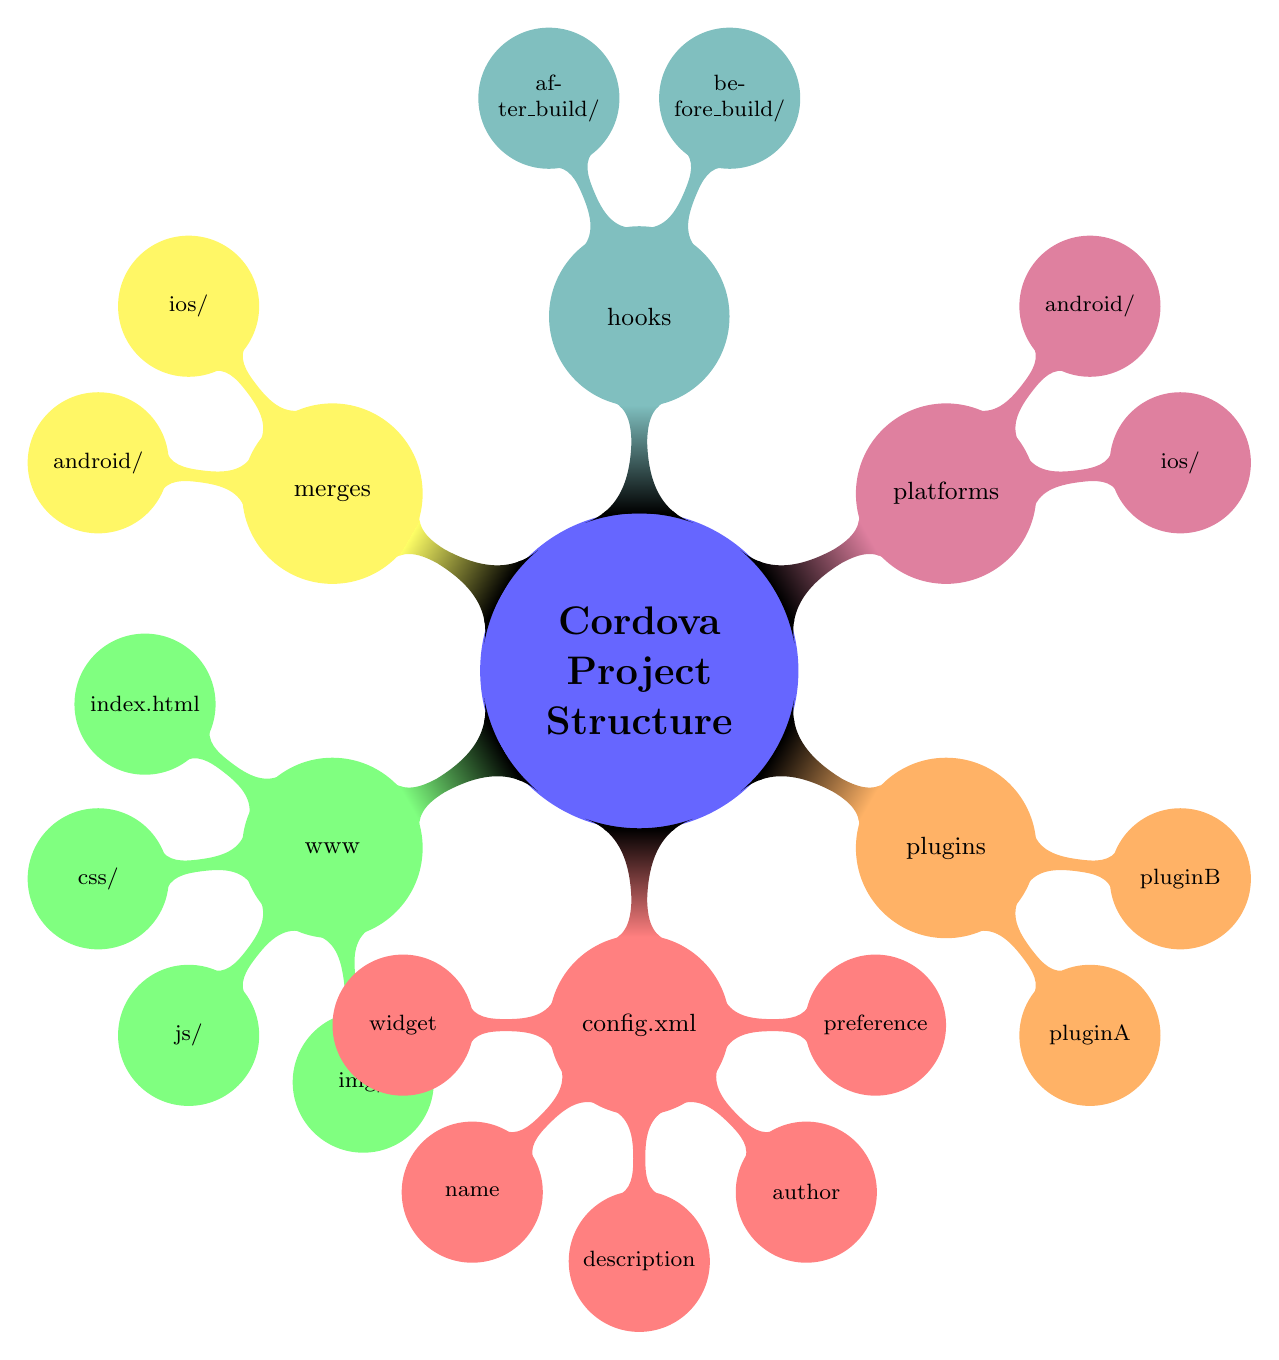What is the main entry point for the application in the www directory? The main entry point for the application is specified as "index.html" within the "www" node, which indicates the starting file when loading the web application.
Answer: index.html How many subdirectories are there under the www directory? The "www" node contains four subdirectories: "css/", "js/", "img/", and a file "index.html". Thus, counting only the subdirectories, there are three.
Answer: 3 What element contains the application's description in the config.xml? In the "config.xml" node, the sub-element "description" indicates where the application's description is stored.
Answer: description Which node describes the platform-specific code? The node labeled "platforms" corresponds specifically to the platform-specific code, detailing separate configurations for different platforms.
Answer: platforms What do the hooks manage in a Cordova project? The "hooks" node contains scripts that run at specific stages during the Cordova project build process, indicating that they are essential for managing build automation.
Answer: scripts How many example plugins are shown in the plugins directory? Within the "plugins" node, there are two example plugin directories listed: "pluginA" and "pluginB". This totals to two plugins represented in the diagram.
Answer: 2 What is the purpose of the merges directory? The "merges" node indicates that it contains platform-specific overrides for content found in the "www" directory, meaning it allows custom content for each platform.
Answer: platform-specific overrides Which platform-specific files are mentioned in the platforms directory? The "platforms" node includes subdirectories for "ios/" and "android/", indicating the presence of platform-specific files for both iOS and Android.
Answer: ios/ and android/ What is the root element in the config.xml? The root element in the "config.xml" node is labeled as "widget," which defines key properties like the application's ID and version.
Answer: widget 